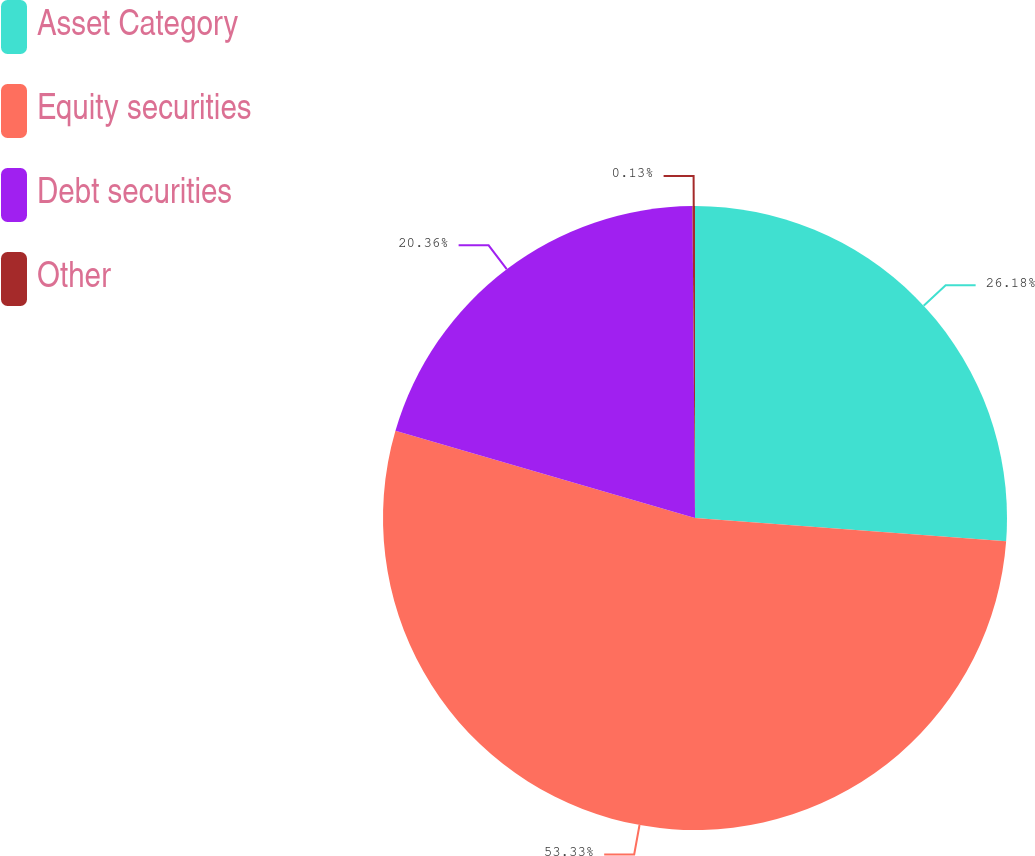Convert chart to OTSL. <chart><loc_0><loc_0><loc_500><loc_500><pie_chart><fcel>Asset Category<fcel>Equity securities<fcel>Debt securities<fcel>Other<nl><fcel>26.18%<fcel>53.32%<fcel>20.36%<fcel>0.13%<nl></chart> 